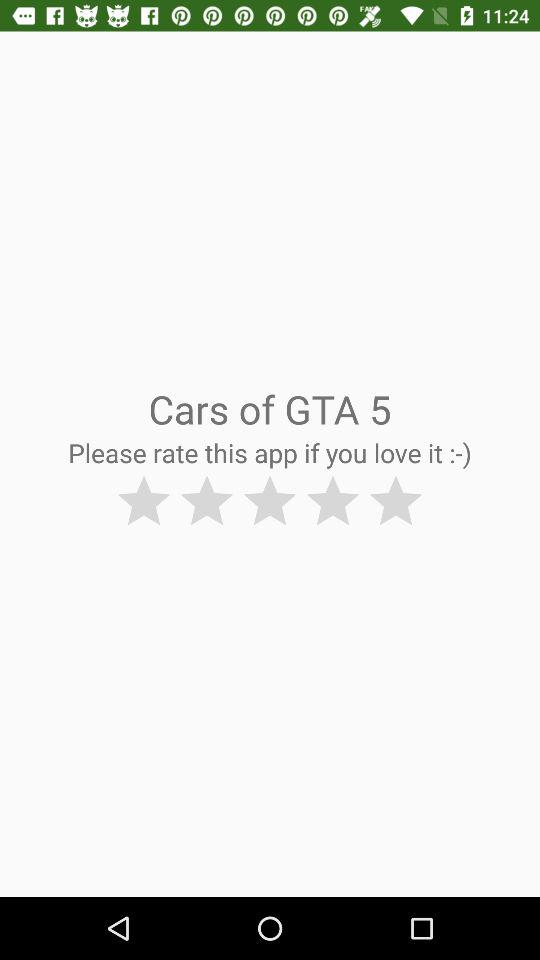Upto what number of stars user can rate the Application?
When the provided information is insufficient, respond with <no answer>. <no answer> 